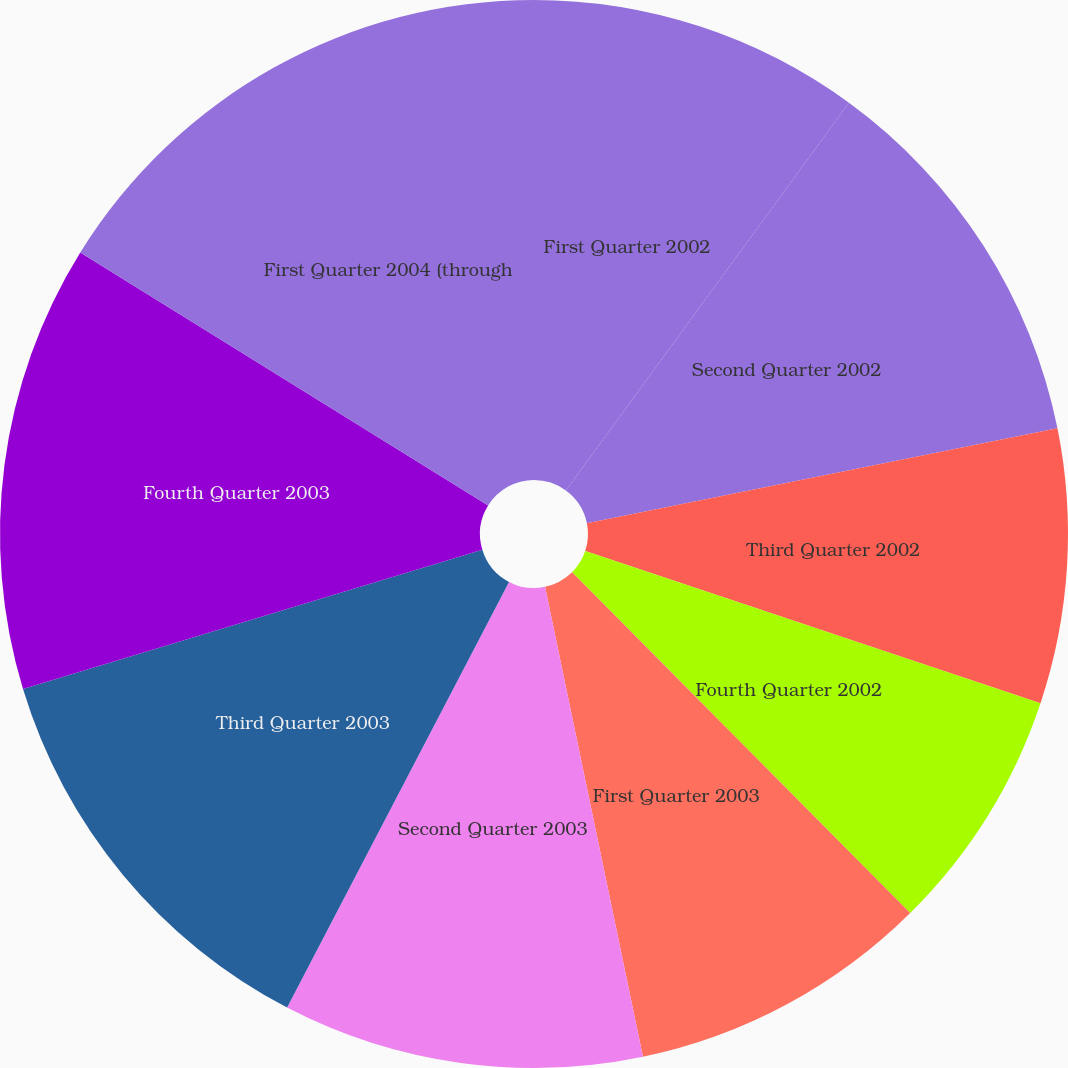Convert chart to OTSL. <chart><loc_0><loc_0><loc_500><loc_500><pie_chart><fcel>First Quarter 2002<fcel>Second Quarter 2002<fcel>Third Quarter 2002<fcel>Fourth Quarter 2002<fcel>First Quarter 2003<fcel>Second Quarter 2003<fcel>Third Quarter 2003<fcel>Fourth Quarter 2003<fcel>First Quarter 2004 (through<nl><fcel>10.04%<fcel>11.79%<fcel>8.3%<fcel>7.43%<fcel>9.17%<fcel>10.92%<fcel>12.66%<fcel>13.53%<fcel>16.16%<nl></chart> 